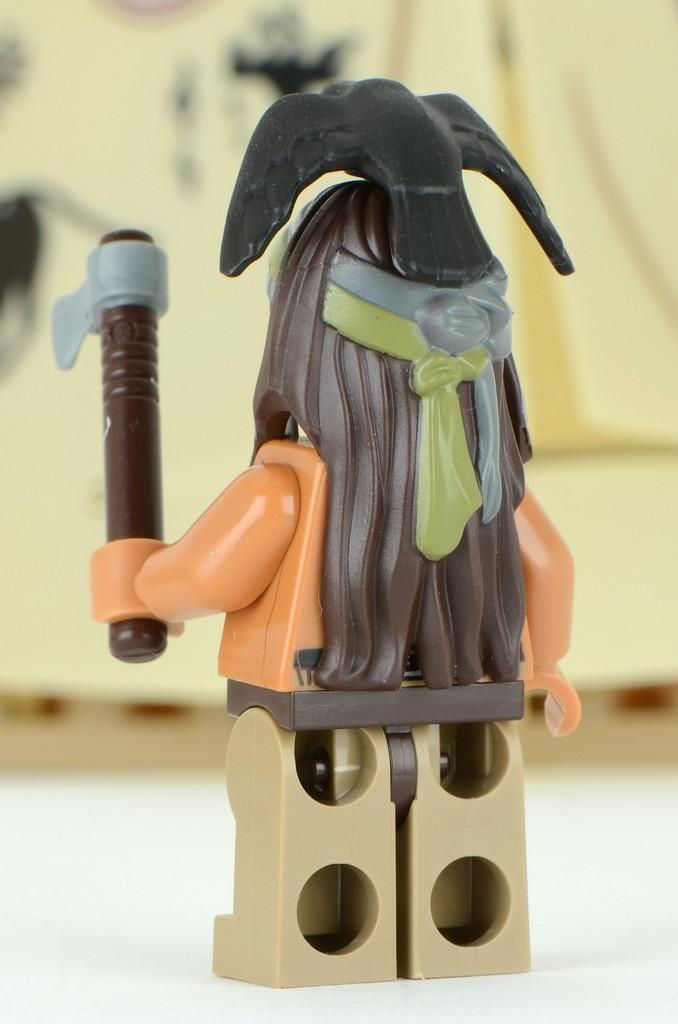What is the main subject of the image? There is a toy in the center of the image. Can you describe the background of the image? The background of the image is blurred. What type of music can be heard coming from the toy in the image? There is no indication in the image that the toy is making any sounds, so it's not possible to determine what, if any, music might be heard. 